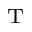Convert formula to latex. <formula><loc_0><loc_0><loc_500><loc_500>_ { T }</formula> 